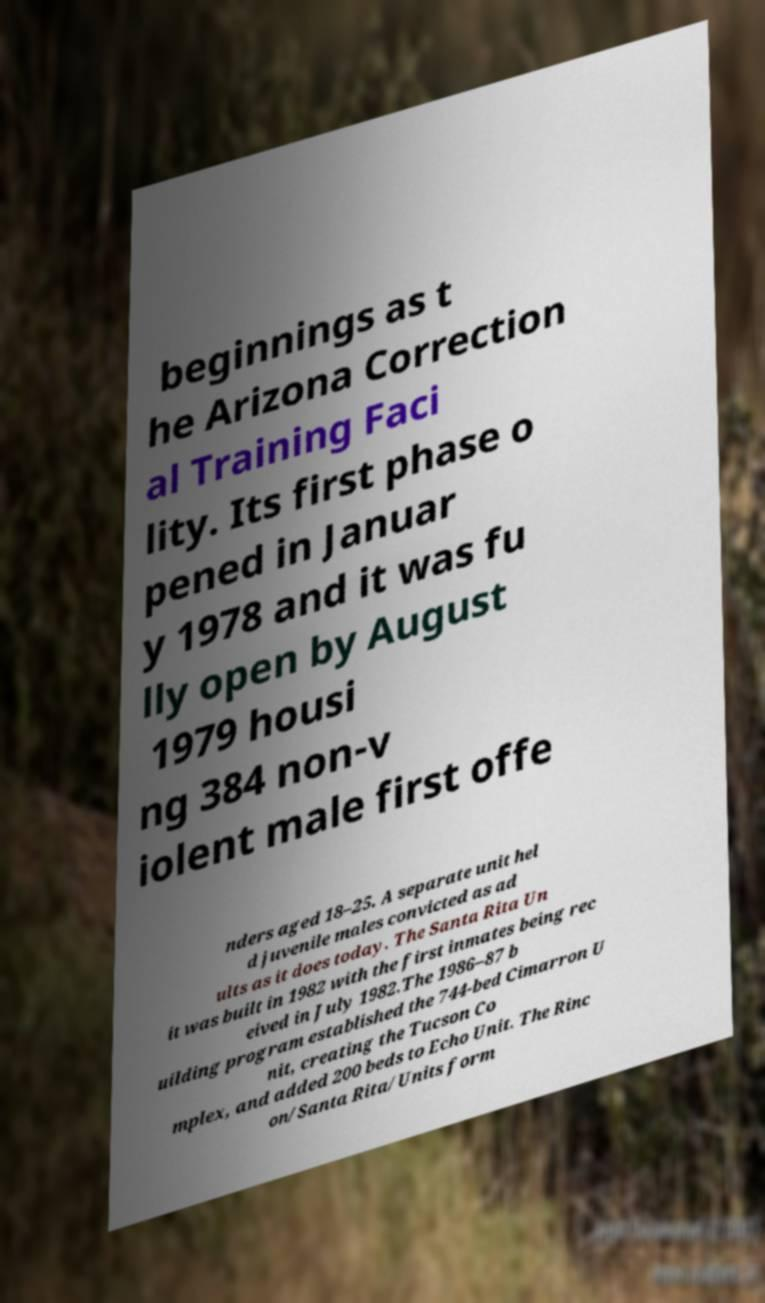I need the written content from this picture converted into text. Can you do that? beginnings as t he Arizona Correction al Training Faci lity. Its first phase o pened in Januar y 1978 and it was fu lly open by August 1979 housi ng 384 non-v iolent male first offe nders aged 18–25. A separate unit hel d juvenile males convicted as ad ults as it does today. The Santa Rita Un it was built in 1982 with the first inmates being rec eived in July 1982.The 1986–87 b uilding program established the 744-bed Cimarron U nit, creating the Tucson Co mplex, and added 200 beds to Echo Unit. The Rinc on/Santa Rita/Units form 